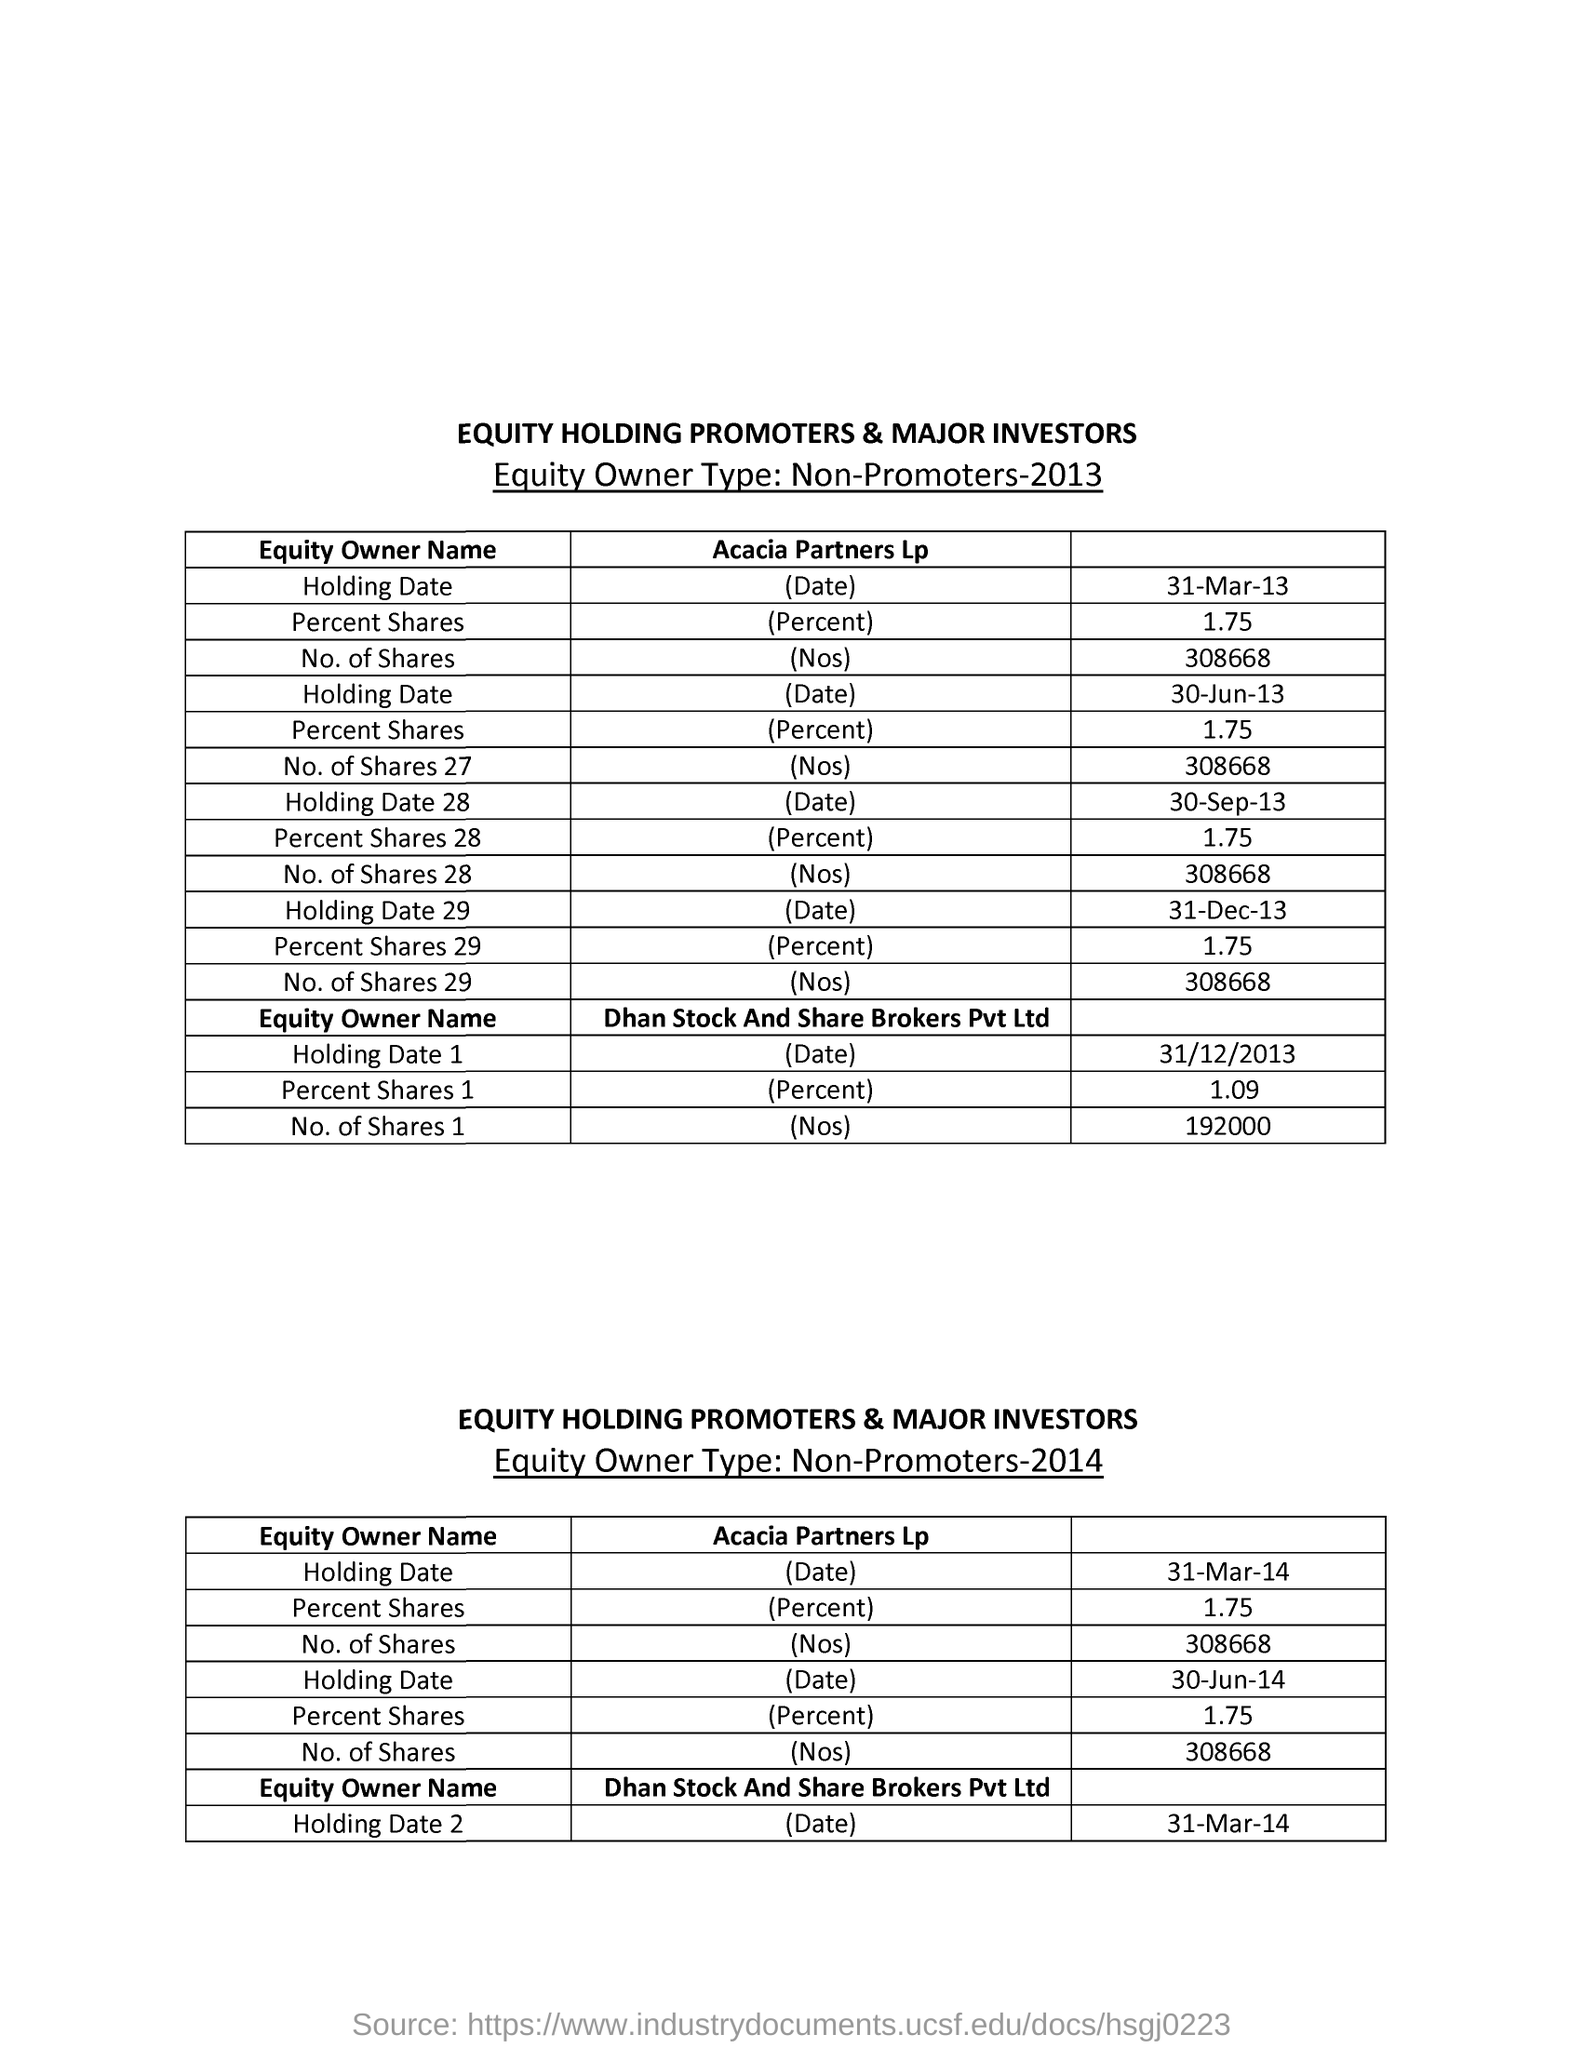What is the table title?
Provide a short and direct response. EQUITY HOLDING PROMOTERS & MAJOR INVESTORS. What is the equity owner type?
Offer a terse response. Non-promoters. 